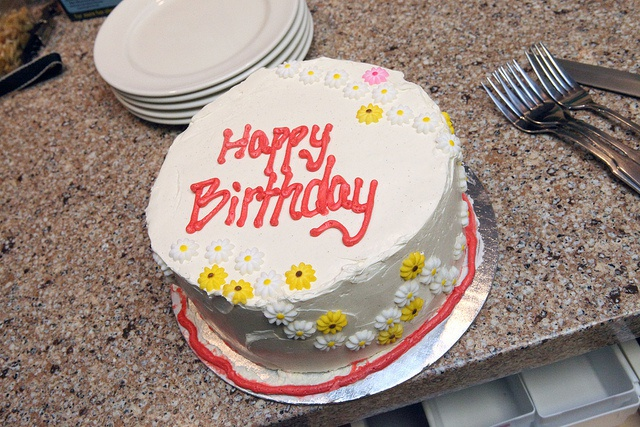Describe the objects in this image and their specific colors. I can see dining table in lightgray, gray, darkgray, and black tones, cake in black, lightgray, darkgray, salmon, and gray tones, bowl in black, gray, and darkgray tones, bowl in black, gray, and purple tones, and fork in black and gray tones in this image. 